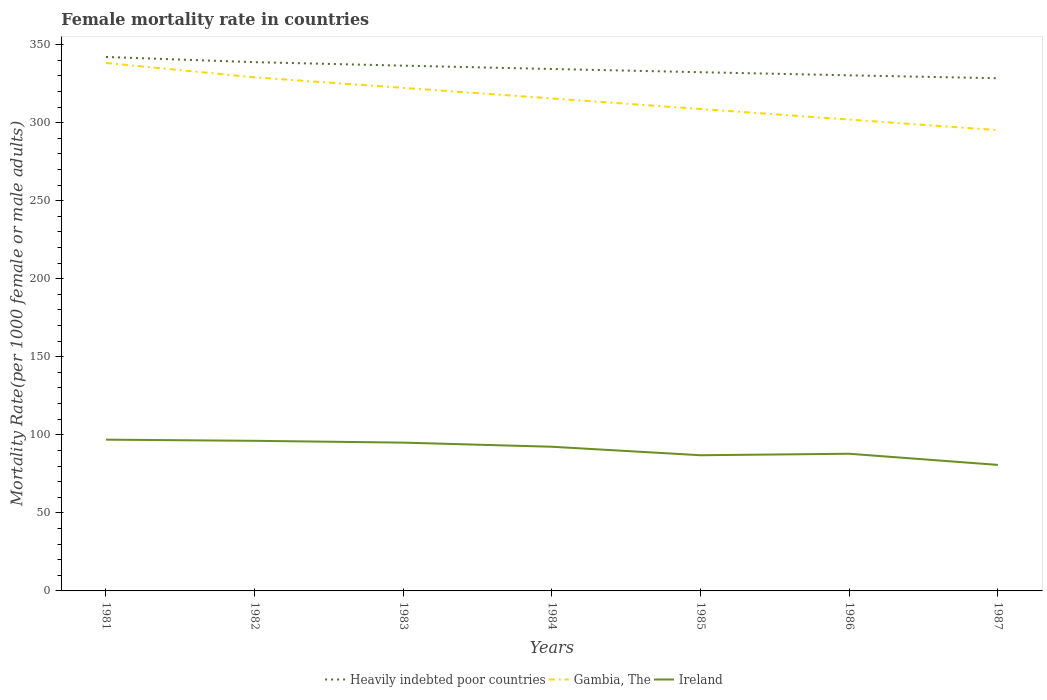Across all years, what is the maximum female mortality rate in Gambia, The?
Provide a short and direct response. 295.18. In which year was the female mortality rate in Heavily indebted poor countries maximum?
Your answer should be compact. 1987. What is the total female mortality rate in Gambia, The in the graph?
Keep it short and to the point. 27.06. What is the difference between the highest and the second highest female mortality rate in Heavily indebted poor countries?
Provide a short and direct response. 13.63. What is the difference between the highest and the lowest female mortality rate in Ireland?
Offer a very short reply. 4. Is the female mortality rate in Heavily indebted poor countries strictly greater than the female mortality rate in Gambia, The over the years?
Give a very brief answer. No. How many lines are there?
Provide a short and direct response. 3. Where does the legend appear in the graph?
Provide a short and direct response. Bottom center. How many legend labels are there?
Your response must be concise. 3. How are the legend labels stacked?
Offer a very short reply. Horizontal. What is the title of the graph?
Provide a succinct answer. Female mortality rate in countries. Does "Burkina Faso" appear as one of the legend labels in the graph?
Your response must be concise. No. What is the label or title of the X-axis?
Provide a succinct answer. Years. What is the label or title of the Y-axis?
Make the answer very short. Mortality Rate(per 1000 female or male adults). What is the Mortality Rate(per 1000 female or male adults) in Heavily indebted poor countries in 1981?
Your answer should be compact. 342.05. What is the Mortality Rate(per 1000 female or male adults) of Gambia, The in 1981?
Offer a very short reply. 338.22. What is the Mortality Rate(per 1000 female or male adults) in Ireland in 1981?
Make the answer very short. 96.9. What is the Mortality Rate(per 1000 female or male adults) in Heavily indebted poor countries in 1982?
Your answer should be compact. 338.72. What is the Mortality Rate(per 1000 female or male adults) of Gambia, The in 1982?
Ensure brevity in your answer.  329.01. What is the Mortality Rate(per 1000 female or male adults) in Ireland in 1982?
Your answer should be very brief. 96.16. What is the Mortality Rate(per 1000 female or male adults) in Heavily indebted poor countries in 1983?
Offer a very short reply. 336.49. What is the Mortality Rate(per 1000 female or male adults) of Gambia, The in 1983?
Keep it short and to the point. 322.24. What is the Mortality Rate(per 1000 female or male adults) of Ireland in 1983?
Keep it short and to the point. 95. What is the Mortality Rate(per 1000 female or male adults) in Heavily indebted poor countries in 1984?
Provide a short and direct response. 334.34. What is the Mortality Rate(per 1000 female or male adults) of Gambia, The in 1984?
Give a very brief answer. 315.47. What is the Mortality Rate(per 1000 female or male adults) of Ireland in 1984?
Ensure brevity in your answer.  92.36. What is the Mortality Rate(per 1000 female or male adults) of Heavily indebted poor countries in 1985?
Your response must be concise. 332.29. What is the Mortality Rate(per 1000 female or male adults) of Gambia, The in 1985?
Offer a terse response. 308.71. What is the Mortality Rate(per 1000 female or male adults) of Ireland in 1985?
Offer a terse response. 86.92. What is the Mortality Rate(per 1000 female or male adults) of Heavily indebted poor countries in 1986?
Ensure brevity in your answer.  330.3. What is the Mortality Rate(per 1000 female or male adults) in Gambia, The in 1986?
Provide a succinct answer. 301.94. What is the Mortality Rate(per 1000 female or male adults) in Ireland in 1986?
Give a very brief answer. 87.87. What is the Mortality Rate(per 1000 female or male adults) in Heavily indebted poor countries in 1987?
Offer a very short reply. 328.42. What is the Mortality Rate(per 1000 female or male adults) in Gambia, The in 1987?
Your answer should be very brief. 295.18. What is the Mortality Rate(per 1000 female or male adults) of Ireland in 1987?
Your answer should be compact. 80.73. Across all years, what is the maximum Mortality Rate(per 1000 female or male adults) in Heavily indebted poor countries?
Offer a very short reply. 342.05. Across all years, what is the maximum Mortality Rate(per 1000 female or male adults) in Gambia, The?
Your answer should be very brief. 338.22. Across all years, what is the maximum Mortality Rate(per 1000 female or male adults) in Ireland?
Keep it short and to the point. 96.9. Across all years, what is the minimum Mortality Rate(per 1000 female or male adults) of Heavily indebted poor countries?
Give a very brief answer. 328.42. Across all years, what is the minimum Mortality Rate(per 1000 female or male adults) of Gambia, The?
Make the answer very short. 295.18. Across all years, what is the minimum Mortality Rate(per 1000 female or male adults) in Ireland?
Ensure brevity in your answer.  80.73. What is the total Mortality Rate(per 1000 female or male adults) of Heavily indebted poor countries in the graph?
Give a very brief answer. 2342.61. What is the total Mortality Rate(per 1000 female or male adults) of Gambia, The in the graph?
Your answer should be compact. 2210.77. What is the total Mortality Rate(per 1000 female or male adults) in Ireland in the graph?
Give a very brief answer. 635.93. What is the difference between the Mortality Rate(per 1000 female or male adults) in Heavily indebted poor countries in 1981 and that in 1982?
Offer a terse response. 3.33. What is the difference between the Mortality Rate(per 1000 female or male adults) of Gambia, The in 1981 and that in 1982?
Give a very brief answer. 9.22. What is the difference between the Mortality Rate(per 1000 female or male adults) in Ireland in 1981 and that in 1982?
Offer a very short reply. 0.73. What is the difference between the Mortality Rate(per 1000 female or male adults) in Heavily indebted poor countries in 1981 and that in 1983?
Provide a succinct answer. 5.55. What is the difference between the Mortality Rate(per 1000 female or male adults) of Gambia, The in 1981 and that in 1983?
Your response must be concise. 15.98. What is the difference between the Mortality Rate(per 1000 female or male adults) of Ireland in 1981 and that in 1983?
Your response must be concise. 1.9. What is the difference between the Mortality Rate(per 1000 female or male adults) in Heavily indebted poor countries in 1981 and that in 1984?
Offer a terse response. 7.7. What is the difference between the Mortality Rate(per 1000 female or male adults) in Gambia, The in 1981 and that in 1984?
Offer a very short reply. 22.75. What is the difference between the Mortality Rate(per 1000 female or male adults) in Ireland in 1981 and that in 1984?
Your answer should be very brief. 4.54. What is the difference between the Mortality Rate(per 1000 female or male adults) of Heavily indebted poor countries in 1981 and that in 1985?
Make the answer very short. 9.76. What is the difference between the Mortality Rate(per 1000 female or male adults) of Gambia, The in 1981 and that in 1985?
Keep it short and to the point. 29.52. What is the difference between the Mortality Rate(per 1000 female or male adults) of Ireland in 1981 and that in 1985?
Offer a terse response. 9.98. What is the difference between the Mortality Rate(per 1000 female or male adults) in Heavily indebted poor countries in 1981 and that in 1986?
Keep it short and to the point. 11.75. What is the difference between the Mortality Rate(per 1000 female or male adults) in Gambia, The in 1981 and that in 1986?
Make the answer very short. 36.28. What is the difference between the Mortality Rate(per 1000 female or male adults) of Ireland in 1981 and that in 1986?
Keep it short and to the point. 9.03. What is the difference between the Mortality Rate(per 1000 female or male adults) of Heavily indebted poor countries in 1981 and that in 1987?
Keep it short and to the point. 13.63. What is the difference between the Mortality Rate(per 1000 female or male adults) of Gambia, The in 1981 and that in 1987?
Your answer should be very brief. 43.05. What is the difference between the Mortality Rate(per 1000 female or male adults) in Ireland in 1981 and that in 1987?
Ensure brevity in your answer.  16.17. What is the difference between the Mortality Rate(per 1000 female or male adults) in Heavily indebted poor countries in 1982 and that in 1983?
Keep it short and to the point. 2.23. What is the difference between the Mortality Rate(per 1000 female or male adults) in Gambia, The in 1982 and that in 1983?
Provide a succinct answer. 6.77. What is the difference between the Mortality Rate(per 1000 female or male adults) in Ireland in 1982 and that in 1983?
Provide a short and direct response. 1.17. What is the difference between the Mortality Rate(per 1000 female or male adults) in Heavily indebted poor countries in 1982 and that in 1984?
Provide a short and direct response. 4.38. What is the difference between the Mortality Rate(per 1000 female or male adults) of Gambia, The in 1982 and that in 1984?
Offer a terse response. 13.53. What is the difference between the Mortality Rate(per 1000 female or male adults) in Ireland in 1982 and that in 1984?
Your answer should be compact. 3.81. What is the difference between the Mortality Rate(per 1000 female or male adults) in Heavily indebted poor countries in 1982 and that in 1985?
Offer a terse response. 6.44. What is the difference between the Mortality Rate(per 1000 female or male adults) of Gambia, The in 1982 and that in 1985?
Your response must be concise. 20.3. What is the difference between the Mortality Rate(per 1000 female or male adults) of Ireland in 1982 and that in 1985?
Provide a short and direct response. 9.24. What is the difference between the Mortality Rate(per 1000 female or male adults) of Heavily indebted poor countries in 1982 and that in 1986?
Give a very brief answer. 8.42. What is the difference between the Mortality Rate(per 1000 female or male adults) in Gambia, The in 1982 and that in 1986?
Provide a short and direct response. 27.06. What is the difference between the Mortality Rate(per 1000 female or male adults) of Ireland in 1982 and that in 1986?
Offer a terse response. 8.29. What is the difference between the Mortality Rate(per 1000 female or male adults) in Heavily indebted poor countries in 1982 and that in 1987?
Give a very brief answer. 10.31. What is the difference between the Mortality Rate(per 1000 female or male adults) of Gambia, The in 1982 and that in 1987?
Offer a very short reply. 33.83. What is the difference between the Mortality Rate(per 1000 female or male adults) of Ireland in 1982 and that in 1987?
Your answer should be compact. 15.43. What is the difference between the Mortality Rate(per 1000 female or male adults) of Heavily indebted poor countries in 1983 and that in 1984?
Give a very brief answer. 2.15. What is the difference between the Mortality Rate(per 1000 female or male adults) in Gambia, The in 1983 and that in 1984?
Provide a succinct answer. 6.77. What is the difference between the Mortality Rate(per 1000 female or male adults) of Ireland in 1983 and that in 1984?
Give a very brief answer. 2.64. What is the difference between the Mortality Rate(per 1000 female or male adults) in Heavily indebted poor countries in 1983 and that in 1985?
Your answer should be compact. 4.21. What is the difference between the Mortality Rate(per 1000 female or male adults) of Gambia, The in 1983 and that in 1985?
Provide a succinct answer. 13.53. What is the difference between the Mortality Rate(per 1000 female or male adults) in Ireland in 1983 and that in 1985?
Your response must be concise. 8.07. What is the difference between the Mortality Rate(per 1000 female or male adults) of Heavily indebted poor countries in 1983 and that in 1986?
Your answer should be compact. 6.2. What is the difference between the Mortality Rate(per 1000 female or male adults) of Gambia, The in 1983 and that in 1986?
Offer a very short reply. 20.3. What is the difference between the Mortality Rate(per 1000 female or male adults) of Ireland in 1983 and that in 1986?
Give a very brief answer. 7.13. What is the difference between the Mortality Rate(per 1000 female or male adults) of Heavily indebted poor countries in 1983 and that in 1987?
Give a very brief answer. 8.08. What is the difference between the Mortality Rate(per 1000 female or male adults) in Gambia, The in 1983 and that in 1987?
Offer a very short reply. 27.06. What is the difference between the Mortality Rate(per 1000 female or male adults) of Ireland in 1983 and that in 1987?
Your answer should be compact. 14.27. What is the difference between the Mortality Rate(per 1000 female or male adults) in Heavily indebted poor countries in 1984 and that in 1985?
Make the answer very short. 2.06. What is the difference between the Mortality Rate(per 1000 female or male adults) in Gambia, The in 1984 and that in 1985?
Your answer should be very brief. 6.76. What is the difference between the Mortality Rate(per 1000 female or male adults) of Ireland in 1984 and that in 1985?
Your response must be concise. 5.44. What is the difference between the Mortality Rate(per 1000 female or male adults) of Heavily indebted poor countries in 1984 and that in 1986?
Provide a short and direct response. 4.05. What is the difference between the Mortality Rate(per 1000 female or male adults) in Gambia, The in 1984 and that in 1986?
Your response must be concise. 13.53. What is the difference between the Mortality Rate(per 1000 female or male adults) in Ireland in 1984 and that in 1986?
Your response must be concise. 4.49. What is the difference between the Mortality Rate(per 1000 female or male adults) in Heavily indebted poor countries in 1984 and that in 1987?
Keep it short and to the point. 5.93. What is the difference between the Mortality Rate(per 1000 female or male adults) in Gambia, The in 1984 and that in 1987?
Your response must be concise. 20.3. What is the difference between the Mortality Rate(per 1000 female or male adults) in Ireland in 1984 and that in 1987?
Offer a terse response. 11.63. What is the difference between the Mortality Rate(per 1000 female or male adults) of Heavily indebted poor countries in 1985 and that in 1986?
Offer a very short reply. 1.99. What is the difference between the Mortality Rate(per 1000 female or male adults) in Gambia, The in 1985 and that in 1986?
Offer a very short reply. 6.77. What is the difference between the Mortality Rate(per 1000 female or male adults) in Ireland in 1985 and that in 1986?
Give a very brief answer. -0.95. What is the difference between the Mortality Rate(per 1000 female or male adults) of Heavily indebted poor countries in 1985 and that in 1987?
Ensure brevity in your answer.  3.87. What is the difference between the Mortality Rate(per 1000 female or male adults) in Gambia, The in 1985 and that in 1987?
Make the answer very short. 13.53. What is the difference between the Mortality Rate(per 1000 female or male adults) of Ireland in 1985 and that in 1987?
Your answer should be very brief. 6.19. What is the difference between the Mortality Rate(per 1000 female or male adults) of Heavily indebted poor countries in 1986 and that in 1987?
Offer a very short reply. 1.88. What is the difference between the Mortality Rate(per 1000 female or male adults) in Gambia, The in 1986 and that in 1987?
Ensure brevity in your answer.  6.76. What is the difference between the Mortality Rate(per 1000 female or male adults) in Ireland in 1986 and that in 1987?
Provide a short and direct response. 7.14. What is the difference between the Mortality Rate(per 1000 female or male adults) of Heavily indebted poor countries in 1981 and the Mortality Rate(per 1000 female or male adults) of Gambia, The in 1982?
Your answer should be compact. 13.04. What is the difference between the Mortality Rate(per 1000 female or male adults) in Heavily indebted poor countries in 1981 and the Mortality Rate(per 1000 female or male adults) in Ireland in 1982?
Your answer should be compact. 245.89. What is the difference between the Mortality Rate(per 1000 female or male adults) of Gambia, The in 1981 and the Mortality Rate(per 1000 female or male adults) of Ireland in 1982?
Offer a very short reply. 242.06. What is the difference between the Mortality Rate(per 1000 female or male adults) in Heavily indebted poor countries in 1981 and the Mortality Rate(per 1000 female or male adults) in Gambia, The in 1983?
Provide a succinct answer. 19.81. What is the difference between the Mortality Rate(per 1000 female or male adults) in Heavily indebted poor countries in 1981 and the Mortality Rate(per 1000 female or male adults) in Ireland in 1983?
Your answer should be very brief. 247.05. What is the difference between the Mortality Rate(per 1000 female or male adults) of Gambia, The in 1981 and the Mortality Rate(per 1000 female or male adults) of Ireland in 1983?
Keep it short and to the point. 243.23. What is the difference between the Mortality Rate(per 1000 female or male adults) of Heavily indebted poor countries in 1981 and the Mortality Rate(per 1000 female or male adults) of Gambia, The in 1984?
Your answer should be very brief. 26.57. What is the difference between the Mortality Rate(per 1000 female or male adults) of Heavily indebted poor countries in 1981 and the Mortality Rate(per 1000 female or male adults) of Ireland in 1984?
Your answer should be compact. 249.69. What is the difference between the Mortality Rate(per 1000 female or male adults) of Gambia, The in 1981 and the Mortality Rate(per 1000 female or male adults) of Ireland in 1984?
Keep it short and to the point. 245.87. What is the difference between the Mortality Rate(per 1000 female or male adults) of Heavily indebted poor countries in 1981 and the Mortality Rate(per 1000 female or male adults) of Gambia, The in 1985?
Offer a very short reply. 33.34. What is the difference between the Mortality Rate(per 1000 female or male adults) in Heavily indebted poor countries in 1981 and the Mortality Rate(per 1000 female or male adults) in Ireland in 1985?
Offer a terse response. 255.13. What is the difference between the Mortality Rate(per 1000 female or male adults) of Gambia, The in 1981 and the Mortality Rate(per 1000 female or male adults) of Ireland in 1985?
Offer a very short reply. 251.3. What is the difference between the Mortality Rate(per 1000 female or male adults) of Heavily indebted poor countries in 1981 and the Mortality Rate(per 1000 female or male adults) of Gambia, The in 1986?
Make the answer very short. 40.11. What is the difference between the Mortality Rate(per 1000 female or male adults) of Heavily indebted poor countries in 1981 and the Mortality Rate(per 1000 female or male adults) of Ireland in 1986?
Give a very brief answer. 254.18. What is the difference between the Mortality Rate(per 1000 female or male adults) of Gambia, The in 1981 and the Mortality Rate(per 1000 female or male adults) of Ireland in 1986?
Your answer should be very brief. 250.35. What is the difference between the Mortality Rate(per 1000 female or male adults) in Heavily indebted poor countries in 1981 and the Mortality Rate(per 1000 female or male adults) in Gambia, The in 1987?
Your answer should be very brief. 46.87. What is the difference between the Mortality Rate(per 1000 female or male adults) of Heavily indebted poor countries in 1981 and the Mortality Rate(per 1000 female or male adults) of Ireland in 1987?
Provide a succinct answer. 261.32. What is the difference between the Mortality Rate(per 1000 female or male adults) of Gambia, The in 1981 and the Mortality Rate(per 1000 female or male adults) of Ireland in 1987?
Your response must be concise. 257.5. What is the difference between the Mortality Rate(per 1000 female or male adults) of Heavily indebted poor countries in 1982 and the Mortality Rate(per 1000 female or male adults) of Gambia, The in 1983?
Offer a terse response. 16.48. What is the difference between the Mortality Rate(per 1000 female or male adults) in Heavily indebted poor countries in 1982 and the Mortality Rate(per 1000 female or male adults) in Ireland in 1983?
Make the answer very short. 243.73. What is the difference between the Mortality Rate(per 1000 female or male adults) of Gambia, The in 1982 and the Mortality Rate(per 1000 female or male adults) of Ireland in 1983?
Provide a short and direct response. 234.01. What is the difference between the Mortality Rate(per 1000 female or male adults) in Heavily indebted poor countries in 1982 and the Mortality Rate(per 1000 female or male adults) in Gambia, The in 1984?
Provide a short and direct response. 23.25. What is the difference between the Mortality Rate(per 1000 female or male adults) of Heavily indebted poor countries in 1982 and the Mortality Rate(per 1000 female or male adults) of Ireland in 1984?
Your response must be concise. 246.37. What is the difference between the Mortality Rate(per 1000 female or male adults) of Gambia, The in 1982 and the Mortality Rate(per 1000 female or male adults) of Ireland in 1984?
Your answer should be compact. 236.65. What is the difference between the Mortality Rate(per 1000 female or male adults) in Heavily indebted poor countries in 1982 and the Mortality Rate(per 1000 female or male adults) in Gambia, The in 1985?
Your response must be concise. 30.01. What is the difference between the Mortality Rate(per 1000 female or male adults) of Heavily indebted poor countries in 1982 and the Mortality Rate(per 1000 female or male adults) of Ireland in 1985?
Offer a very short reply. 251.8. What is the difference between the Mortality Rate(per 1000 female or male adults) in Gambia, The in 1982 and the Mortality Rate(per 1000 female or male adults) in Ireland in 1985?
Give a very brief answer. 242.09. What is the difference between the Mortality Rate(per 1000 female or male adults) in Heavily indebted poor countries in 1982 and the Mortality Rate(per 1000 female or male adults) in Gambia, The in 1986?
Provide a succinct answer. 36.78. What is the difference between the Mortality Rate(per 1000 female or male adults) in Heavily indebted poor countries in 1982 and the Mortality Rate(per 1000 female or male adults) in Ireland in 1986?
Provide a succinct answer. 250.85. What is the difference between the Mortality Rate(per 1000 female or male adults) in Gambia, The in 1982 and the Mortality Rate(per 1000 female or male adults) in Ireland in 1986?
Your answer should be compact. 241.14. What is the difference between the Mortality Rate(per 1000 female or male adults) of Heavily indebted poor countries in 1982 and the Mortality Rate(per 1000 female or male adults) of Gambia, The in 1987?
Offer a terse response. 43.55. What is the difference between the Mortality Rate(per 1000 female or male adults) of Heavily indebted poor countries in 1982 and the Mortality Rate(per 1000 female or male adults) of Ireland in 1987?
Offer a terse response. 258. What is the difference between the Mortality Rate(per 1000 female or male adults) of Gambia, The in 1982 and the Mortality Rate(per 1000 female or male adults) of Ireland in 1987?
Provide a short and direct response. 248.28. What is the difference between the Mortality Rate(per 1000 female or male adults) in Heavily indebted poor countries in 1983 and the Mortality Rate(per 1000 female or male adults) in Gambia, The in 1984?
Offer a terse response. 21.02. What is the difference between the Mortality Rate(per 1000 female or male adults) in Heavily indebted poor countries in 1983 and the Mortality Rate(per 1000 female or male adults) in Ireland in 1984?
Keep it short and to the point. 244.14. What is the difference between the Mortality Rate(per 1000 female or male adults) of Gambia, The in 1983 and the Mortality Rate(per 1000 female or male adults) of Ireland in 1984?
Offer a terse response. 229.88. What is the difference between the Mortality Rate(per 1000 female or male adults) in Heavily indebted poor countries in 1983 and the Mortality Rate(per 1000 female or male adults) in Gambia, The in 1985?
Provide a short and direct response. 27.79. What is the difference between the Mortality Rate(per 1000 female or male adults) in Heavily indebted poor countries in 1983 and the Mortality Rate(per 1000 female or male adults) in Ireland in 1985?
Ensure brevity in your answer.  249.57. What is the difference between the Mortality Rate(per 1000 female or male adults) of Gambia, The in 1983 and the Mortality Rate(per 1000 female or male adults) of Ireland in 1985?
Provide a short and direct response. 235.32. What is the difference between the Mortality Rate(per 1000 female or male adults) in Heavily indebted poor countries in 1983 and the Mortality Rate(per 1000 female or male adults) in Gambia, The in 1986?
Keep it short and to the point. 34.55. What is the difference between the Mortality Rate(per 1000 female or male adults) in Heavily indebted poor countries in 1983 and the Mortality Rate(per 1000 female or male adults) in Ireland in 1986?
Make the answer very short. 248.62. What is the difference between the Mortality Rate(per 1000 female or male adults) in Gambia, The in 1983 and the Mortality Rate(per 1000 female or male adults) in Ireland in 1986?
Ensure brevity in your answer.  234.37. What is the difference between the Mortality Rate(per 1000 female or male adults) in Heavily indebted poor countries in 1983 and the Mortality Rate(per 1000 female or male adults) in Gambia, The in 1987?
Provide a short and direct response. 41.32. What is the difference between the Mortality Rate(per 1000 female or male adults) of Heavily indebted poor countries in 1983 and the Mortality Rate(per 1000 female or male adults) of Ireland in 1987?
Make the answer very short. 255.77. What is the difference between the Mortality Rate(per 1000 female or male adults) of Gambia, The in 1983 and the Mortality Rate(per 1000 female or male adults) of Ireland in 1987?
Offer a very short reply. 241.51. What is the difference between the Mortality Rate(per 1000 female or male adults) of Heavily indebted poor countries in 1984 and the Mortality Rate(per 1000 female or male adults) of Gambia, The in 1985?
Provide a short and direct response. 25.63. What is the difference between the Mortality Rate(per 1000 female or male adults) of Heavily indebted poor countries in 1984 and the Mortality Rate(per 1000 female or male adults) of Ireland in 1985?
Offer a very short reply. 247.42. What is the difference between the Mortality Rate(per 1000 female or male adults) in Gambia, The in 1984 and the Mortality Rate(per 1000 female or male adults) in Ireland in 1985?
Your answer should be very brief. 228.55. What is the difference between the Mortality Rate(per 1000 female or male adults) in Heavily indebted poor countries in 1984 and the Mortality Rate(per 1000 female or male adults) in Gambia, The in 1986?
Offer a terse response. 32.4. What is the difference between the Mortality Rate(per 1000 female or male adults) of Heavily indebted poor countries in 1984 and the Mortality Rate(per 1000 female or male adults) of Ireland in 1986?
Make the answer very short. 246.47. What is the difference between the Mortality Rate(per 1000 female or male adults) in Gambia, The in 1984 and the Mortality Rate(per 1000 female or male adults) in Ireland in 1986?
Ensure brevity in your answer.  227.6. What is the difference between the Mortality Rate(per 1000 female or male adults) of Heavily indebted poor countries in 1984 and the Mortality Rate(per 1000 female or male adults) of Gambia, The in 1987?
Offer a terse response. 39.17. What is the difference between the Mortality Rate(per 1000 female or male adults) in Heavily indebted poor countries in 1984 and the Mortality Rate(per 1000 female or male adults) in Ireland in 1987?
Provide a short and direct response. 253.62. What is the difference between the Mortality Rate(per 1000 female or male adults) in Gambia, The in 1984 and the Mortality Rate(per 1000 female or male adults) in Ireland in 1987?
Your answer should be compact. 234.75. What is the difference between the Mortality Rate(per 1000 female or male adults) in Heavily indebted poor countries in 1985 and the Mortality Rate(per 1000 female or male adults) in Gambia, The in 1986?
Your response must be concise. 30.34. What is the difference between the Mortality Rate(per 1000 female or male adults) of Heavily indebted poor countries in 1985 and the Mortality Rate(per 1000 female or male adults) of Ireland in 1986?
Make the answer very short. 244.42. What is the difference between the Mortality Rate(per 1000 female or male adults) of Gambia, The in 1985 and the Mortality Rate(per 1000 female or male adults) of Ireland in 1986?
Your answer should be compact. 220.84. What is the difference between the Mortality Rate(per 1000 female or male adults) in Heavily indebted poor countries in 1985 and the Mortality Rate(per 1000 female or male adults) in Gambia, The in 1987?
Give a very brief answer. 37.11. What is the difference between the Mortality Rate(per 1000 female or male adults) in Heavily indebted poor countries in 1985 and the Mortality Rate(per 1000 female or male adults) in Ireland in 1987?
Make the answer very short. 251.56. What is the difference between the Mortality Rate(per 1000 female or male adults) in Gambia, The in 1985 and the Mortality Rate(per 1000 female or male adults) in Ireland in 1987?
Provide a succinct answer. 227.98. What is the difference between the Mortality Rate(per 1000 female or male adults) in Heavily indebted poor countries in 1986 and the Mortality Rate(per 1000 female or male adults) in Gambia, The in 1987?
Your answer should be compact. 35.12. What is the difference between the Mortality Rate(per 1000 female or male adults) of Heavily indebted poor countries in 1986 and the Mortality Rate(per 1000 female or male adults) of Ireland in 1987?
Your answer should be very brief. 249.57. What is the difference between the Mortality Rate(per 1000 female or male adults) of Gambia, The in 1986 and the Mortality Rate(per 1000 female or male adults) of Ireland in 1987?
Offer a very short reply. 221.22. What is the average Mortality Rate(per 1000 female or male adults) in Heavily indebted poor countries per year?
Give a very brief answer. 334.66. What is the average Mortality Rate(per 1000 female or male adults) in Gambia, The per year?
Offer a terse response. 315.82. What is the average Mortality Rate(per 1000 female or male adults) of Ireland per year?
Your response must be concise. 90.85. In the year 1981, what is the difference between the Mortality Rate(per 1000 female or male adults) in Heavily indebted poor countries and Mortality Rate(per 1000 female or male adults) in Gambia, The?
Offer a terse response. 3.82. In the year 1981, what is the difference between the Mortality Rate(per 1000 female or male adults) in Heavily indebted poor countries and Mortality Rate(per 1000 female or male adults) in Ireland?
Give a very brief answer. 245.15. In the year 1981, what is the difference between the Mortality Rate(per 1000 female or male adults) in Gambia, The and Mortality Rate(per 1000 female or male adults) in Ireland?
Offer a very short reply. 241.33. In the year 1982, what is the difference between the Mortality Rate(per 1000 female or male adults) of Heavily indebted poor countries and Mortality Rate(per 1000 female or male adults) of Gambia, The?
Provide a succinct answer. 9.72. In the year 1982, what is the difference between the Mortality Rate(per 1000 female or male adults) in Heavily indebted poor countries and Mortality Rate(per 1000 female or male adults) in Ireland?
Your answer should be compact. 242.56. In the year 1982, what is the difference between the Mortality Rate(per 1000 female or male adults) of Gambia, The and Mortality Rate(per 1000 female or male adults) of Ireland?
Make the answer very short. 232.84. In the year 1983, what is the difference between the Mortality Rate(per 1000 female or male adults) in Heavily indebted poor countries and Mortality Rate(per 1000 female or male adults) in Gambia, The?
Your answer should be very brief. 14.25. In the year 1983, what is the difference between the Mortality Rate(per 1000 female or male adults) of Heavily indebted poor countries and Mortality Rate(per 1000 female or male adults) of Ireland?
Your answer should be compact. 241.5. In the year 1983, what is the difference between the Mortality Rate(per 1000 female or male adults) of Gambia, The and Mortality Rate(per 1000 female or male adults) of Ireland?
Your answer should be compact. 227.25. In the year 1984, what is the difference between the Mortality Rate(per 1000 female or male adults) in Heavily indebted poor countries and Mortality Rate(per 1000 female or male adults) in Gambia, The?
Offer a terse response. 18.87. In the year 1984, what is the difference between the Mortality Rate(per 1000 female or male adults) in Heavily indebted poor countries and Mortality Rate(per 1000 female or male adults) in Ireland?
Offer a terse response. 241.99. In the year 1984, what is the difference between the Mortality Rate(per 1000 female or male adults) in Gambia, The and Mortality Rate(per 1000 female or male adults) in Ireland?
Make the answer very short. 223.12. In the year 1985, what is the difference between the Mortality Rate(per 1000 female or male adults) of Heavily indebted poor countries and Mortality Rate(per 1000 female or male adults) of Gambia, The?
Keep it short and to the point. 23.58. In the year 1985, what is the difference between the Mortality Rate(per 1000 female or male adults) of Heavily indebted poor countries and Mortality Rate(per 1000 female or male adults) of Ireland?
Provide a short and direct response. 245.37. In the year 1985, what is the difference between the Mortality Rate(per 1000 female or male adults) in Gambia, The and Mortality Rate(per 1000 female or male adults) in Ireland?
Make the answer very short. 221.79. In the year 1986, what is the difference between the Mortality Rate(per 1000 female or male adults) of Heavily indebted poor countries and Mortality Rate(per 1000 female or male adults) of Gambia, The?
Offer a very short reply. 28.36. In the year 1986, what is the difference between the Mortality Rate(per 1000 female or male adults) of Heavily indebted poor countries and Mortality Rate(per 1000 female or male adults) of Ireland?
Provide a short and direct response. 242.43. In the year 1986, what is the difference between the Mortality Rate(per 1000 female or male adults) in Gambia, The and Mortality Rate(per 1000 female or male adults) in Ireland?
Offer a terse response. 214.07. In the year 1987, what is the difference between the Mortality Rate(per 1000 female or male adults) in Heavily indebted poor countries and Mortality Rate(per 1000 female or male adults) in Gambia, The?
Provide a short and direct response. 33.24. In the year 1987, what is the difference between the Mortality Rate(per 1000 female or male adults) in Heavily indebted poor countries and Mortality Rate(per 1000 female or male adults) in Ireland?
Ensure brevity in your answer.  247.69. In the year 1987, what is the difference between the Mortality Rate(per 1000 female or male adults) of Gambia, The and Mortality Rate(per 1000 female or male adults) of Ireland?
Ensure brevity in your answer.  214.45. What is the ratio of the Mortality Rate(per 1000 female or male adults) in Heavily indebted poor countries in 1981 to that in 1982?
Offer a terse response. 1.01. What is the ratio of the Mortality Rate(per 1000 female or male adults) in Gambia, The in 1981 to that in 1982?
Offer a terse response. 1.03. What is the ratio of the Mortality Rate(per 1000 female or male adults) in Ireland in 1981 to that in 1982?
Offer a terse response. 1.01. What is the ratio of the Mortality Rate(per 1000 female or male adults) of Heavily indebted poor countries in 1981 to that in 1983?
Offer a very short reply. 1.02. What is the ratio of the Mortality Rate(per 1000 female or male adults) of Gambia, The in 1981 to that in 1983?
Your answer should be very brief. 1.05. What is the ratio of the Mortality Rate(per 1000 female or male adults) of Ireland in 1981 to that in 1983?
Your answer should be very brief. 1.02. What is the ratio of the Mortality Rate(per 1000 female or male adults) of Heavily indebted poor countries in 1981 to that in 1984?
Make the answer very short. 1.02. What is the ratio of the Mortality Rate(per 1000 female or male adults) of Gambia, The in 1981 to that in 1984?
Ensure brevity in your answer.  1.07. What is the ratio of the Mortality Rate(per 1000 female or male adults) in Ireland in 1981 to that in 1984?
Keep it short and to the point. 1.05. What is the ratio of the Mortality Rate(per 1000 female or male adults) in Heavily indebted poor countries in 1981 to that in 1985?
Keep it short and to the point. 1.03. What is the ratio of the Mortality Rate(per 1000 female or male adults) in Gambia, The in 1981 to that in 1985?
Provide a short and direct response. 1.1. What is the ratio of the Mortality Rate(per 1000 female or male adults) of Ireland in 1981 to that in 1985?
Keep it short and to the point. 1.11. What is the ratio of the Mortality Rate(per 1000 female or male adults) of Heavily indebted poor countries in 1981 to that in 1986?
Give a very brief answer. 1.04. What is the ratio of the Mortality Rate(per 1000 female or male adults) in Gambia, The in 1981 to that in 1986?
Provide a succinct answer. 1.12. What is the ratio of the Mortality Rate(per 1000 female or male adults) of Ireland in 1981 to that in 1986?
Offer a terse response. 1.1. What is the ratio of the Mortality Rate(per 1000 female or male adults) in Heavily indebted poor countries in 1981 to that in 1987?
Your answer should be very brief. 1.04. What is the ratio of the Mortality Rate(per 1000 female or male adults) in Gambia, The in 1981 to that in 1987?
Your answer should be very brief. 1.15. What is the ratio of the Mortality Rate(per 1000 female or male adults) of Ireland in 1981 to that in 1987?
Your answer should be very brief. 1.2. What is the ratio of the Mortality Rate(per 1000 female or male adults) in Heavily indebted poor countries in 1982 to that in 1983?
Your answer should be compact. 1.01. What is the ratio of the Mortality Rate(per 1000 female or male adults) of Gambia, The in 1982 to that in 1983?
Give a very brief answer. 1.02. What is the ratio of the Mortality Rate(per 1000 female or male adults) of Ireland in 1982 to that in 1983?
Provide a short and direct response. 1.01. What is the ratio of the Mortality Rate(per 1000 female or male adults) in Heavily indebted poor countries in 1982 to that in 1984?
Your answer should be compact. 1.01. What is the ratio of the Mortality Rate(per 1000 female or male adults) of Gambia, The in 1982 to that in 1984?
Ensure brevity in your answer.  1.04. What is the ratio of the Mortality Rate(per 1000 female or male adults) of Ireland in 1982 to that in 1984?
Your answer should be very brief. 1.04. What is the ratio of the Mortality Rate(per 1000 female or male adults) in Heavily indebted poor countries in 1982 to that in 1985?
Your answer should be compact. 1.02. What is the ratio of the Mortality Rate(per 1000 female or male adults) of Gambia, The in 1982 to that in 1985?
Your answer should be compact. 1.07. What is the ratio of the Mortality Rate(per 1000 female or male adults) of Ireland in 1982 to that in 1985?
Offer a terse response. 1.11. What is the ratio of the Mortality Rate(per 1000 female or male adults) in Heavily indebted poor countries in 1982 to that in 1986?
Your answer should be very brief. 1.03. What is the ratio of the Mortality Rate(per 1000 female or male adults) of Gambia, The in 1982 to that in 1986?
Your answer should be compact. 1.09. What is the ratio of the Mortality Rate(per 1000 female or male adults) of Ireland in 1982 to that in 1986?
Offer a very short reply. 1.09. What is the ratio of the Mortality Rate(per 1000 female or male adults) of Heavily indebted poor countries in 1982 to that in 1987?
Offer a very short reply. 1.03. What is the ratio of the Mortality Rate(per 1000 female or male adults) of Gambia, The in 1982 to that in 1987?
Provide a short and direct response. 1.11. What is the ratio of the Mortality Rate(per 1000 female or male adults) of Ireland in 1982 to that in 1987?
Your response must be concise. 1.19. What is the ratio of the Mortality Rate(per 1000 female or male adults) of Heavily indebted poor countries in 1983 to that in 1984?
Provide a succinct answer. 1.01. What is the ratio of the Mortality Rate(per 1000 female or male adults) in Gambia, The in 1983 to that in 1984?
Give a very brief answer. 1.02. What is the ratio of the Mortality Rate(per 1000 female or male adults) of Ireland in 1983 to that in 1984?
Keep it short and to the point. 1.03. What is the ratio of the Mortality Rate(per 1000 female or male adults) in Heavily indebted poor countries in 1983 to that in 1985?
Keep it short and to the point. 1.01. What is the ratio of the Mortality Rate(per 1000 female or male adults) in Gambia, The in 1983 to that in 1985?
Ensure brevity in your answer.  1.04. What is the ratio of the Mortality Rate(per 1000 female or male adults) of Ireland in 1983 to that in 1985?
Your response must be concise. 1.09. What is the ratio of the Mortality Rate(per 1000 female or male adults) in Heavily indebted poor countries in 1983 to that in 1986?
Provide a short and direct response. 1.02. What is the ratio of the Mortality Rate(per 1000 female or male adults) of Gambia, The in 1983 to that in 1986?
Offer a very short reply. 1.07. What is the ratio of the Mortality Rate(per 1000 female or male adults) of Ireland in 1983 to that in 1986?
Keep it short and to the point. 1.08. What is the ratio of the Mortality Rate(per 1000 female or male adults) in Heavily indebted poor countries in 1983 to that in 1987?
Your answer should be compact. 1.02. What is the ratio of the Mortality Rate(per 1000 female or male adults) of Gambia, The in 1983 to that in 1987?
Offer a terse response. 1.09. What is the ratio of the Mortality Rate(per 1000 female or male adults) of Ireland in 1983 to that in 1987?
Ensure brevity in your answer.  1.18. What is the ratio of the Mortality Rate(per 1000 female or male adults) of Gambia, The in 1984 to that in 1985?
Your answer should be very brief. 1.02. What is the ratio of the Mortality Rate(per 1000 female or male adults) in Ireland in 1984 to that in 1985?
Make the answer very short. 1.06. What is the ratio of the Mortality Rate(per 1000 female or male adults) in Heavily indebted poor countries in 1984 to that in 1986?
Give a very brief answer. 1.01. What is the ratio of the Mortality Rate(per 1000 female or male adults) of Gambia, The in 1984 to that in 1986?
Provide a short and direct response. 1.04. What is the ratio of the Mortality Rate(per 1000 female or male adults) in Ireland in 1984 to that in 1986?
Give a very brief answer. 1.05. What is the ratio of the Mortality Rate(per 1000 female or male adults) in Gambia, The in 1984 to that in 1987?
Give a very brief answer. 1.07. What is the ratio of the Mortality Rate(per 1000 female or male adults) in Ireland in 1984 to that in 1987?
Make the answer very short. 1.14. What is the ratio of the Mortality Rate(per 1000 female or male adults) in Heavily indebted poor countries in 1985 to that in 1986?
Your response must be concise. 1.01. What is the ratio of the Mortality Rate(per 1000 female or male adults) of Gambia, The in 1985 to that in 1986?
Offer a terse response. 1.02. What is the ratio of the Mortality Rate(per 1000 female or male adults) in Heavily indebted poor countries in 1985 to that in 1987?
Your response must be concise. 1.01. What is the ratio of the Mortality Rate(per 1000 female or male adults) of Gambia, The in 1985 to that in 1987?
Offer a terse response. 1.05. What is the ratio of the Mortality Rate(per 1000 female or male adults) in Ireland in 1985 to that in 1987?
Offer a very short reply. 1.08. What is the ratio of the Mortality Rate(per 1000 female or male adults) in Gambia, The in 1986 to that in 1987?
Provide a short and direct response. 1.02. What is the ratio of the Mortality Rate(per 1000 female or male adults) in Ireland in 1986 to that in 1987?
Your answer should be compact. 1.09. What is the difference between the highest and the second highest Mortality Rate(per 1000 female or male adults) of Heavily indebted poor countries?
Keep it short and to the point. 3.33. What is the difference between the highest and the second highest Mortality Rate(per 1000 female or male adults) in Gambia, The?
Provide a succinct answer. 9.22. What is the difference between the highest and the second highest Mortality Rate(per 1000 female or male adults) of Ireland?
Give a very brief answer. 0.73. What is the difference between the highest and the lowest Mortality Rate(per 1000 female or male adults) in Heavily indebted poor countries?
Provide a succinct answer. 13.63. What is the difference between the highest and the lowest Mortality Rate(per 1000 female or male adults) in Gambia, The?
Your response must be concise. 43.05. What is the difference between the highest and the lowest Mortality Rate(per 1000 female or male adults) of Ireland?
Provide a succinct answer. 16.17. 